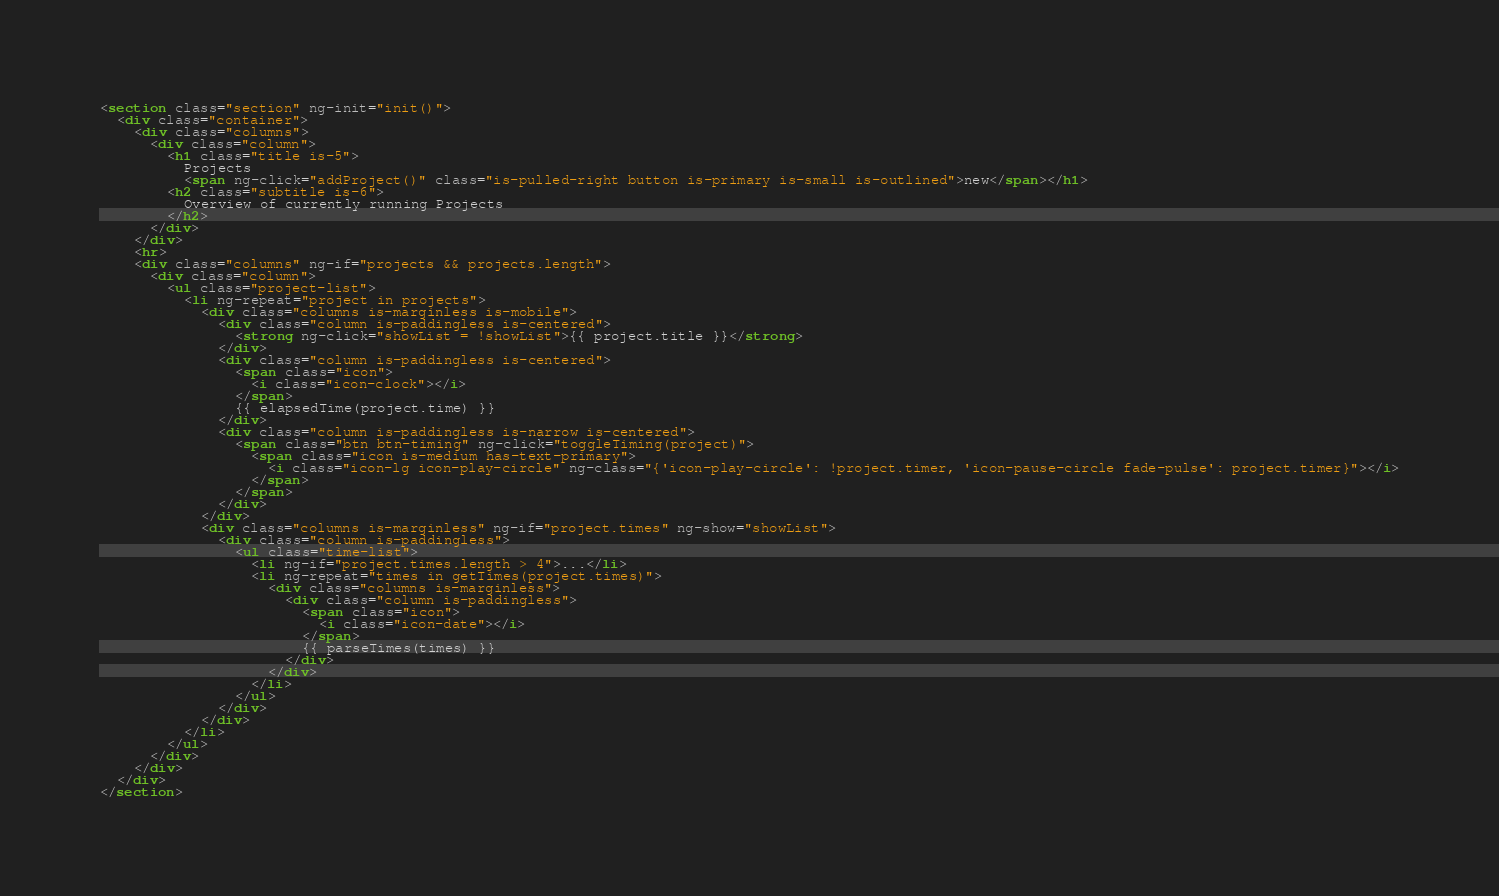Convert code to text. <code><loc_0><loc_0><loc_500><loc_500><_HTML_><section class="section" ng-init="init()">
  <div class="container">
    <div class="columns">
      <div class="column">
        <h1 class="title is-5">
          Projects
          <span ng-click="addProject()" class="is-pulled-right button is-primary is-small is-outlined">new</span></h1>
        <h2 class="subtitle is-6">
          Overview of currently running Projects
        </h2>
      </div>
    </div>
    <hr>
    <div class="columns" ng-if="projects && projects.length">
      <div class="column">
        <ul class="project-list">
          <li ng-repeat="project in projects">
            <div class="columns is-marginless is-mobile">
              <div class="column is-paddingless is-centered">
                <strong ng-click="showList = !showList">{{ project.title }}</strong>
              </div>
              <div class="column is-paddingless is-centered">
                <span class="icon">
                  <i class="icon-clock"></i>
                </span>
                {{ elapsedTime(project.time) }}
              </div>
              <div class="column is-paddingless is-narrow is-centered">
                <span class="btn btn-timing" ng-click="toggleTiming(project)">
                  <span class="icon is-medium has-text-primary">
                    <i class="icon-lg icon-play-circle" ng-class="{'icon-play-circle': !project.timer, 'icon-pause-circle fade-pulse': project.timer}"></i>
                  </span>
                </span>
              </div>
            </div>
            <div class="columns is-marginless" ng-if="project.times" ng-show="showList">
              <div class="column is-paddingless">
                <ul class="time-list">
                  <li ng-if="project.times.length > 4">...</li>
                  <li ng-repeat="times in getTimes(project.times)">
                    <div class="columns is-marginless">
                      <div class="column is-paddingless">
                        <span class="icon">
                          <i class="icon-date"></i>
                        </span>
                        {{ parseTimes(times) }}
                      </div>
                    </div>
                  </li>
                </ul>
              </div>
            </div>
          </li>
        </ul>
      </div>
    </div>
  </div>
</section>
</code> 